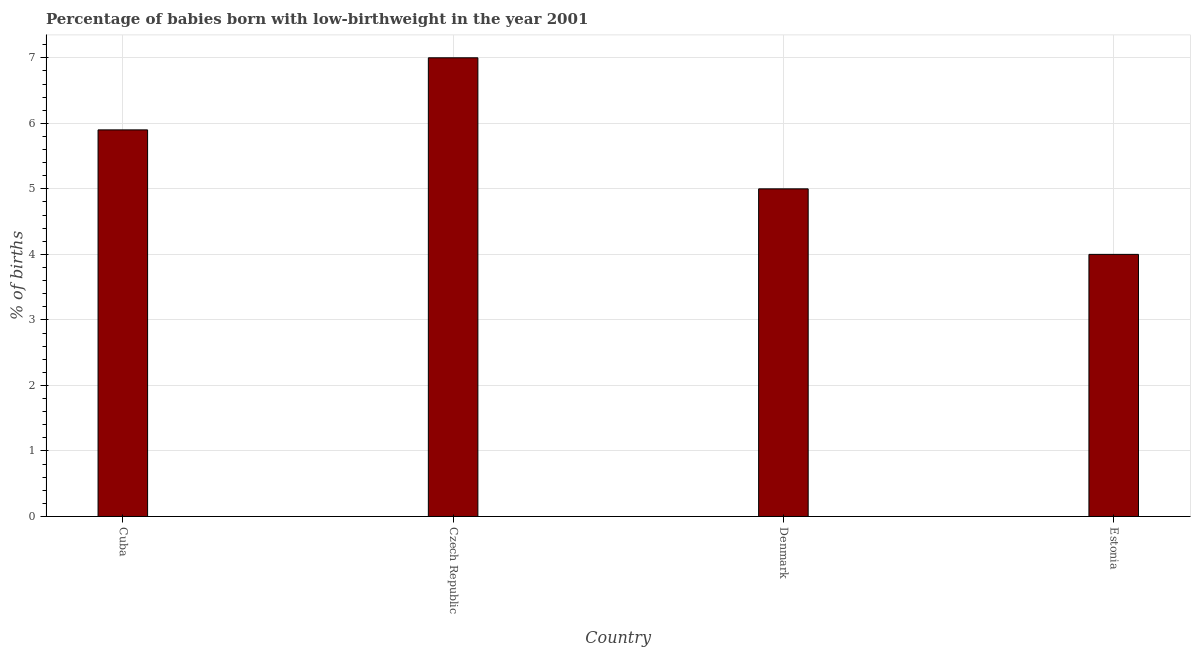Does the graph contain grids?
Your answer should be compact. Yes. What is the title of the graph?
Your answer should be compact. Percentage of babies born with low-birthweight in the year 2001. What is the label or title of the Y-axis?
Offer a very short reply. % of births. Across all countries, what is the maximum percentage of babies who were born with low-birthweight?
Your response must be concise. 7. Across all countries, what is the minimum percentage of babies who were born with low-birthweight?
Your response must be concise. 4. In which country was the percentage of babies who were born with low-birthweight maximum?
Your answer should be very brief. Czech Republic. In which country was the percentage of babies who were born with low-birthweight minimum?
Offer a terse response. Estonia. What is the sum of the percentage of babies who were born with low-birthweight?
Ensure brevity in your answer.  21.9. What is the difference between the percentage of babies who were born with low-birthweight in Czech Republic and Estonia?
Make the answer very short. 3. What is the average percentage of babies who were born with low-birthweight per country?
Make the answer very short. 5.47. What is the median percentage of babies who were born with low-birthweight?
Offer a terse response. 5.45. What is the ratio of the percentage of babies who were born with low-birthweight in Cuba to that in Czech Republic?
Offer a terse response. 0.84. Is the percentage of babies who were born with low-birthweight in Czech Republic less than that in Denmark?
Offer a terse response. No. What is the difference between the highest and the lowest percentage of babies who were born with low-birthweight?
Your response must be concise. 3. Are all the bars in the graph horizontal?
Your response must be concise. No. How many countries are there in the graph?
Provide a short and direct response. 4. What is the difference between two consecutive major ticks on the Y-axis?
Provide a short and direct response. 1. Are the values on the major ticks of Y-axis written in scientific E-notation?
Ensure brevity in your answer.  No. What is the % of births in Denmark?
Provide a succinct answer. 5. What is the difference between the % of births in Czech Republic and Denmark?
Give a very brief answer. 2. What is the difference between the % of births in Denmark and Estonia?
Provide a succinct answer. 1. What is the ratio of the % of births in Cuba to that in Czech Republic?
Your response must be concise. 0.84. What is the ratio of the % of births in Cuba to that in Denmark?
Make the answer very short. 1.18. What is the ratio of the % of births in Cuba to that in Estonia?
Provide a short and direct response. 1.48. What is the ratio of the % of births in Czech Republic to that in Estonia?
Give a very brief answer. 1.75. 